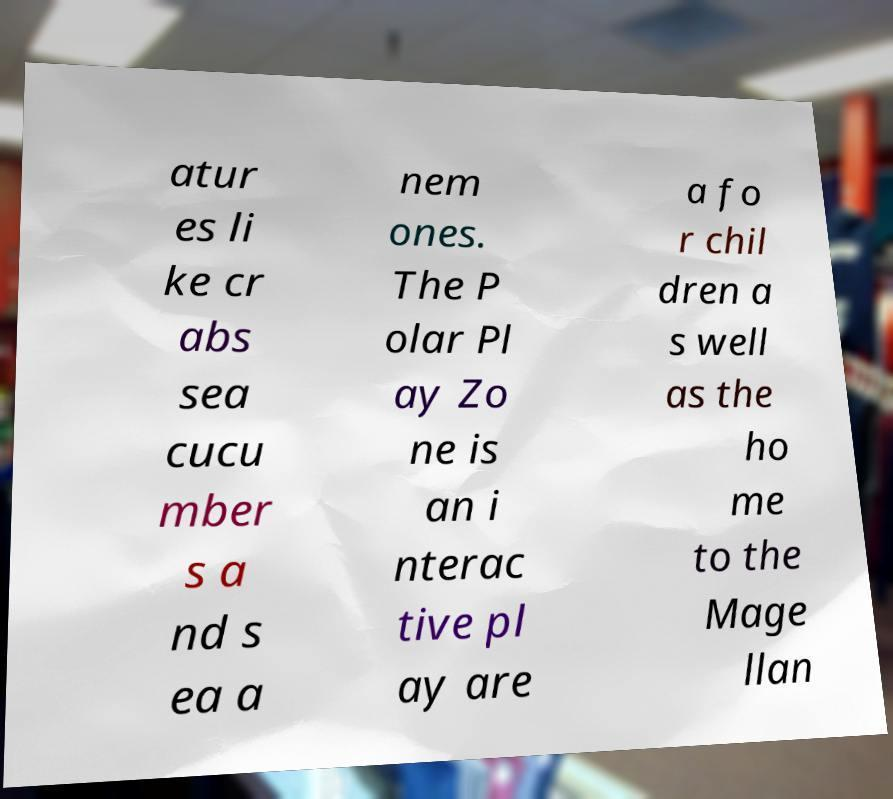I need the written content from this picture converted into text. Can you do that? atur es li ke cr abs sea cucu mber s a nd s ea a nem ones. The P olar Pl ay Zo ne is an i nterac tive pl ay are a fo r chil dren a s well as the ho me to the Mage llan 